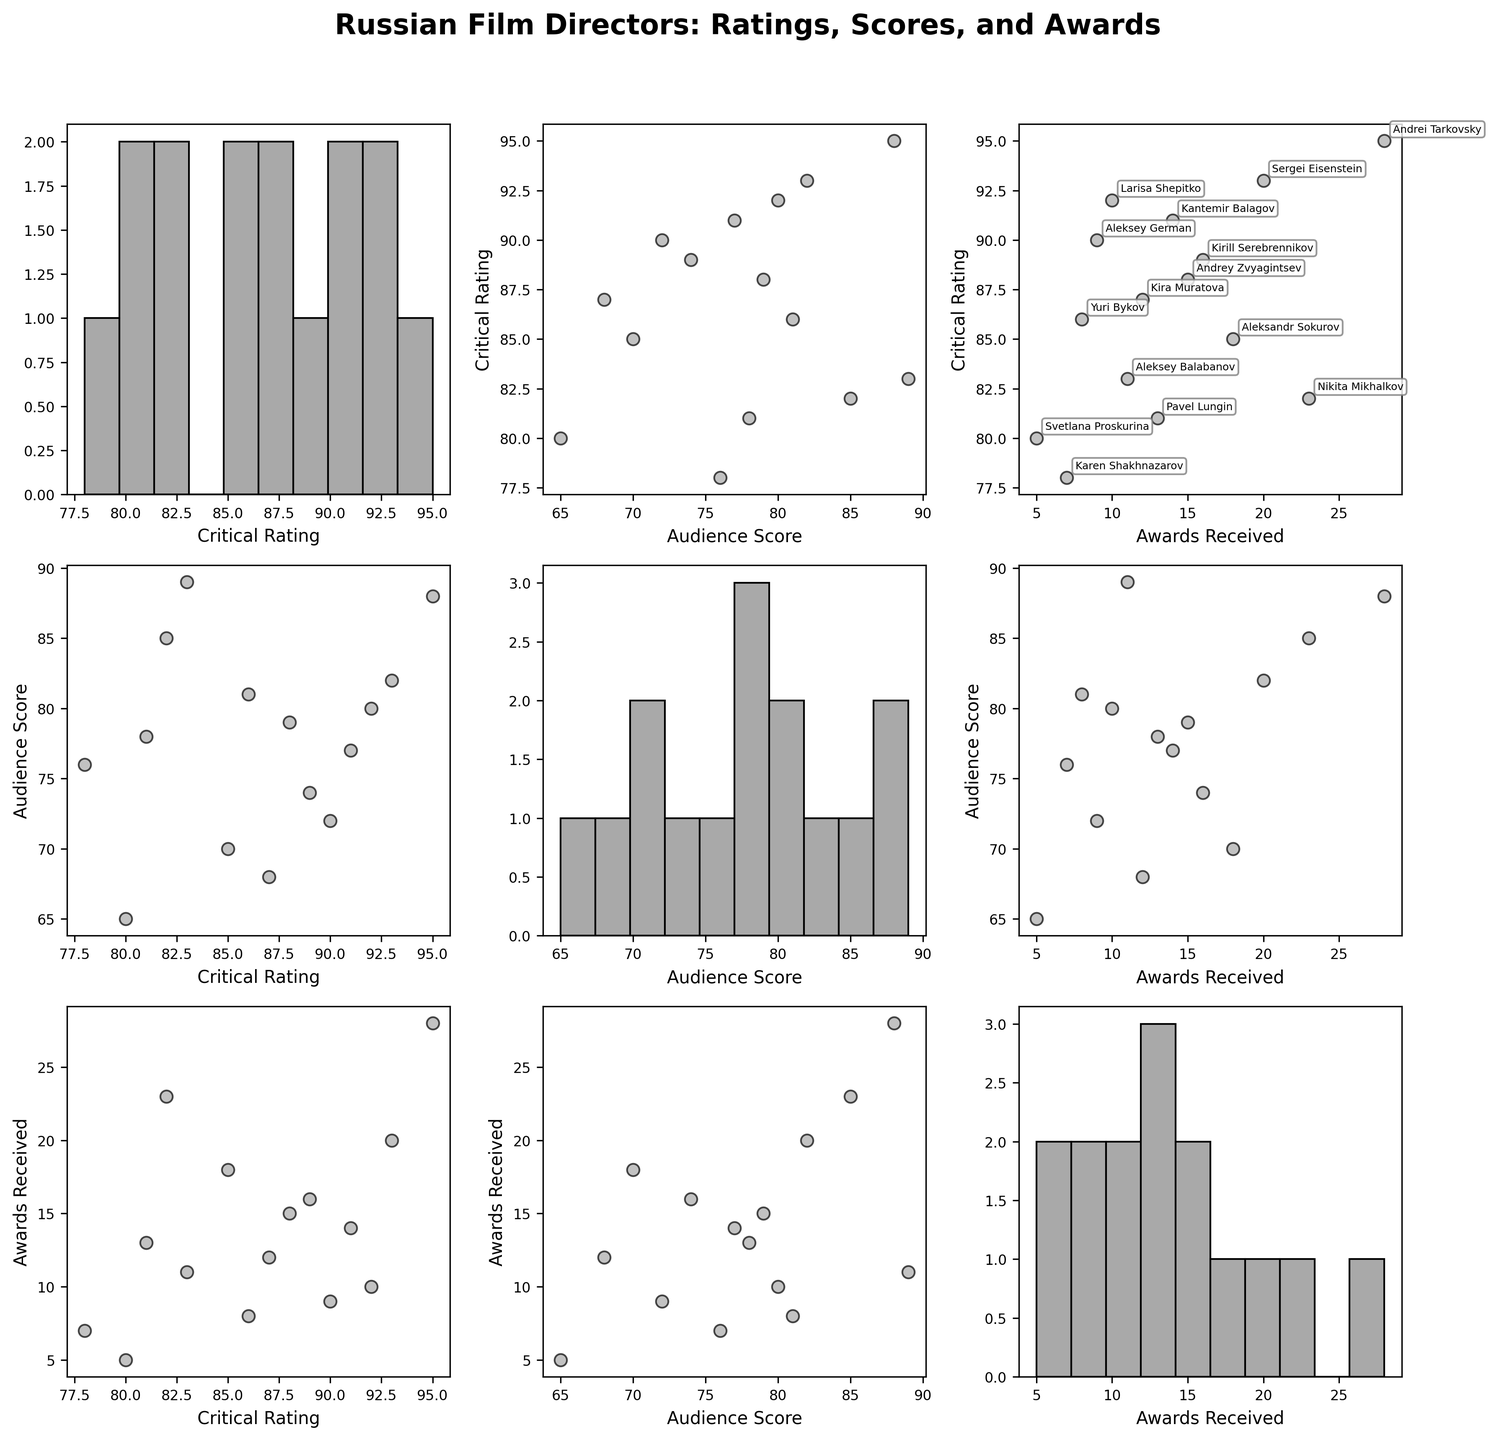What is the title of the scatterplot matrix? The title of the scatterplot matrix is displayed at the top of the figure in bold font and larger size to signify its importance.
Answer: Russian Film Directors: Ratings, Scores, and Awards How many directors have their Audience Scores represented in the figure? The scatterplot matrix consists of multiple plots where each plot includes audience scores. Counting the unique directors will give us the answer.
Answer: 15 Which director has the highest Critical Rating? Locate the critical rating axis, find the highest value and identify the associated director annotated near that data point.
Answer: Andrei Tarkovsky Who has received the most awards among the directors in the dataset? Find the "Awards Received" axis, locate the highest value on the scatterplot matrix, and note the director's name annotated near that point.
Answer: Andrei Tarkovsky What is the average Audience Score of directors with a Critical Rating above 85? Identify directors with Critical Ratings above 85, sum their Audience Scores, and divide by the number of those directors.
Answer: 78.6 Among directors with more than 15 awards, who has the lowest Audience Score? Filter directors with more than 15 awards, check their Audience Scores, and identify the lowest one.
Answer: Aleksandr Sokurov Which two directors have the closest Audience Scores? Compare all Audience Scores and identify the two scores with the smallest difference.
Answer: Andrey Zvyagintsev and Pavel Lungin How many directors have both a Critical Rating higher than 90 and have won more than 10 awards? Identify directors who meet both criteria: Critical Rating > 90 and Awards > 10, then count them.
Answer: 3 Is there a strong correlation between Critical Ratings and Audience Scores based on the scatterplots? Examine the scatterplot comparing Critical Ratings and Audience Scores to see if points tend to line up along a trend line, indicating correlation strength.
Answer: Yes, there is a visible positive correlation Based on the scatterplot matrix, which variable seems to have the least variation? Check the histograms along the diagonal of the scatterplot matrix to determine which variable's histogram shows the least spread.
Answer: Awards Received 